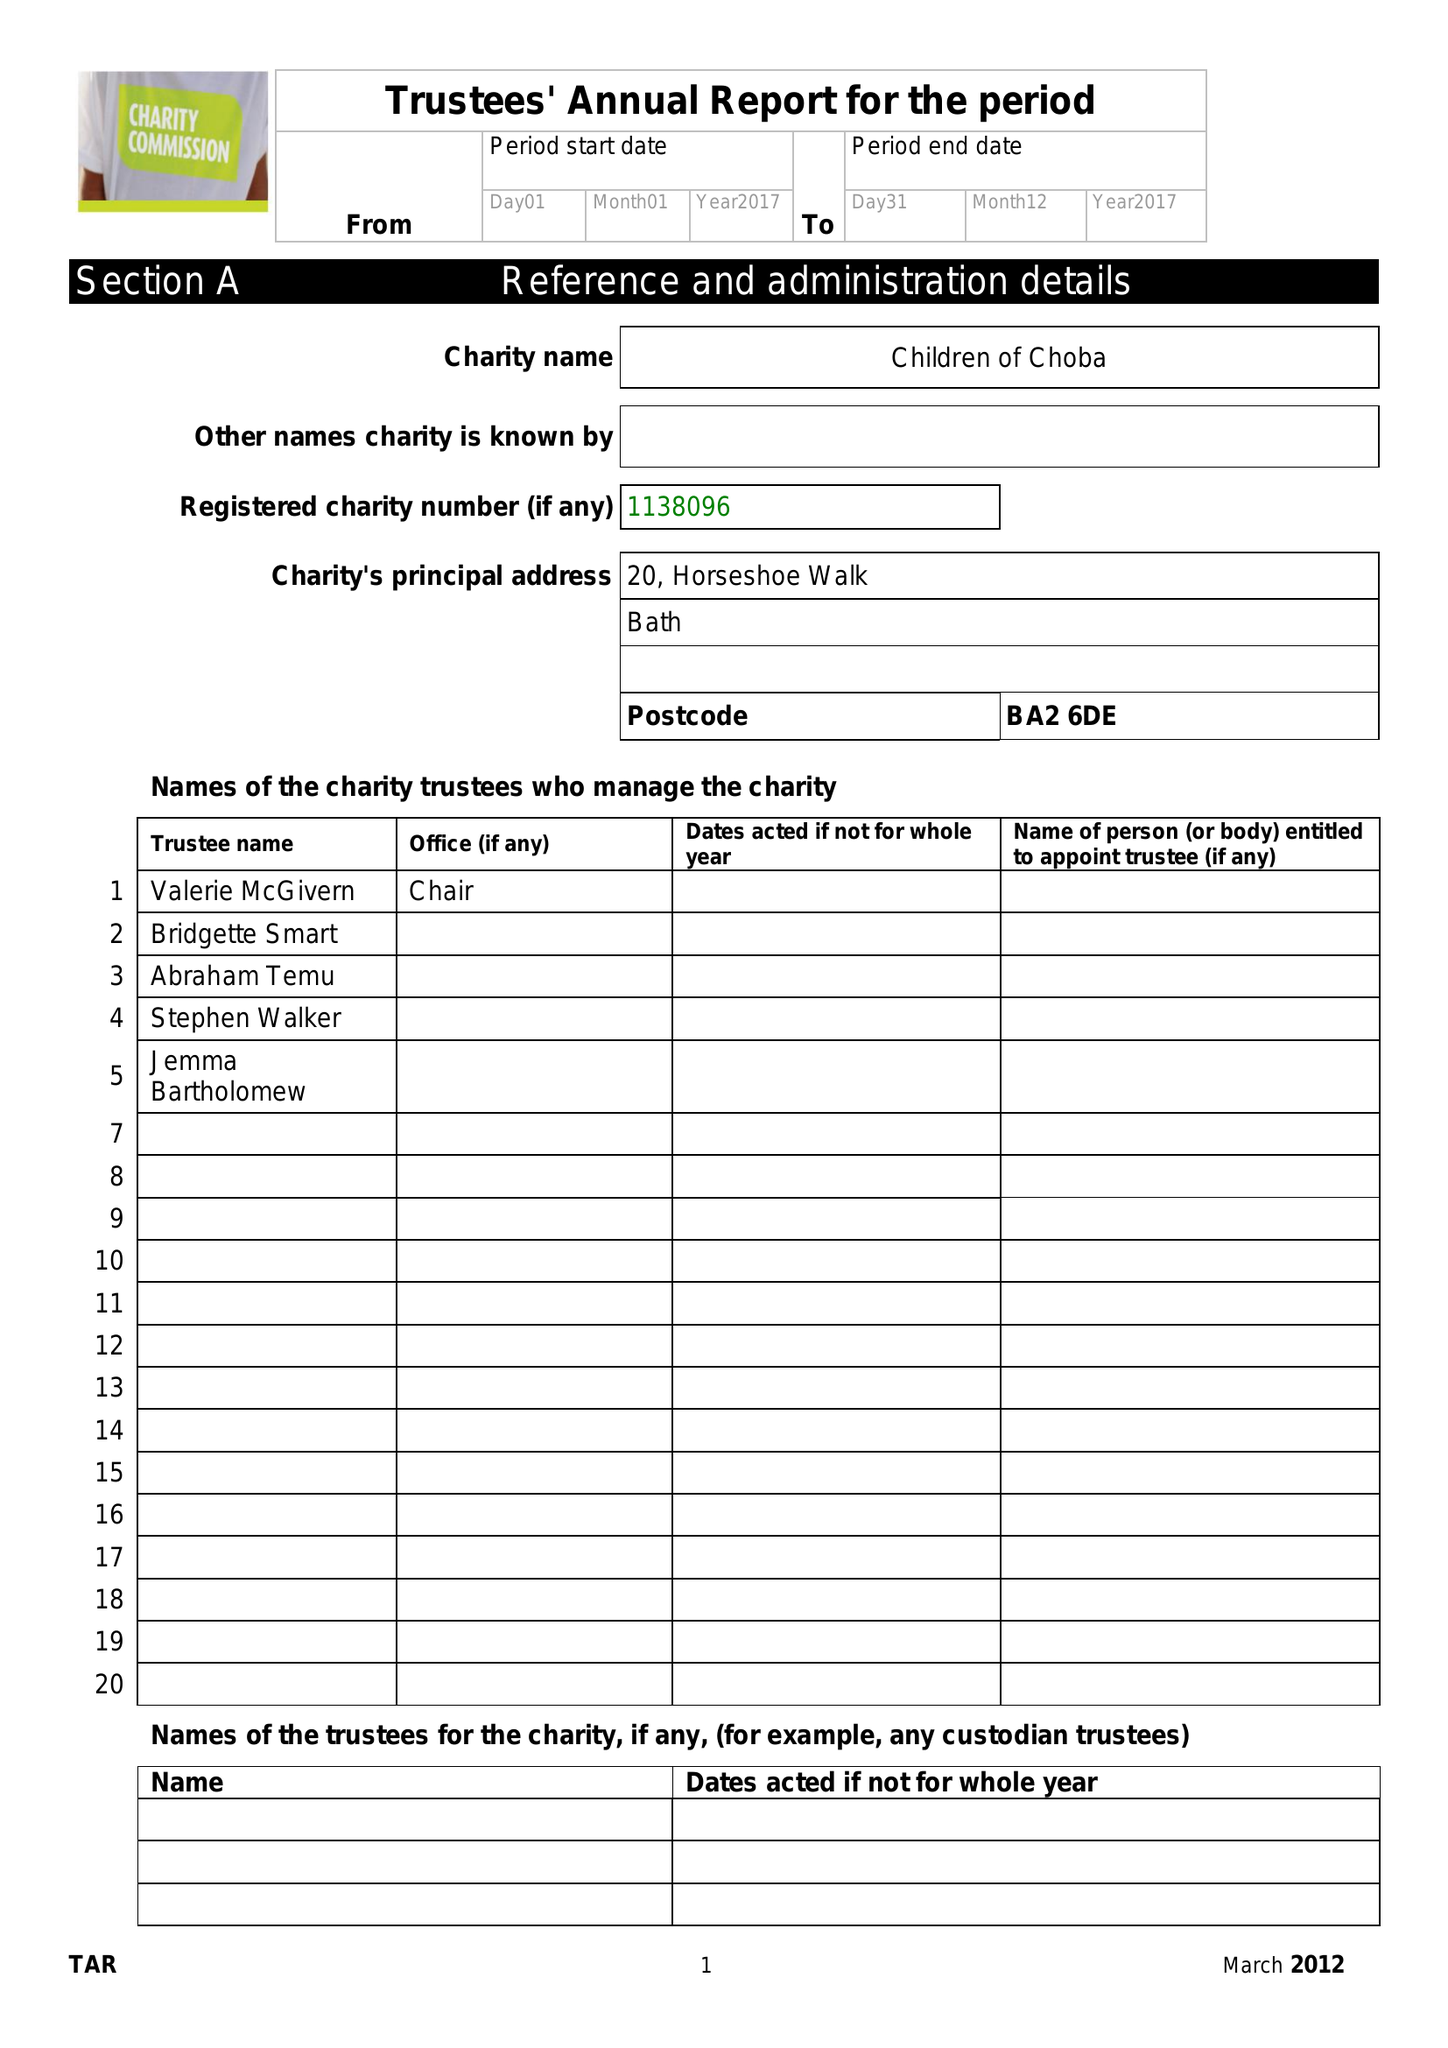What is the value for the charity_number?
Answer the question using a single word or phrase. 1138096 